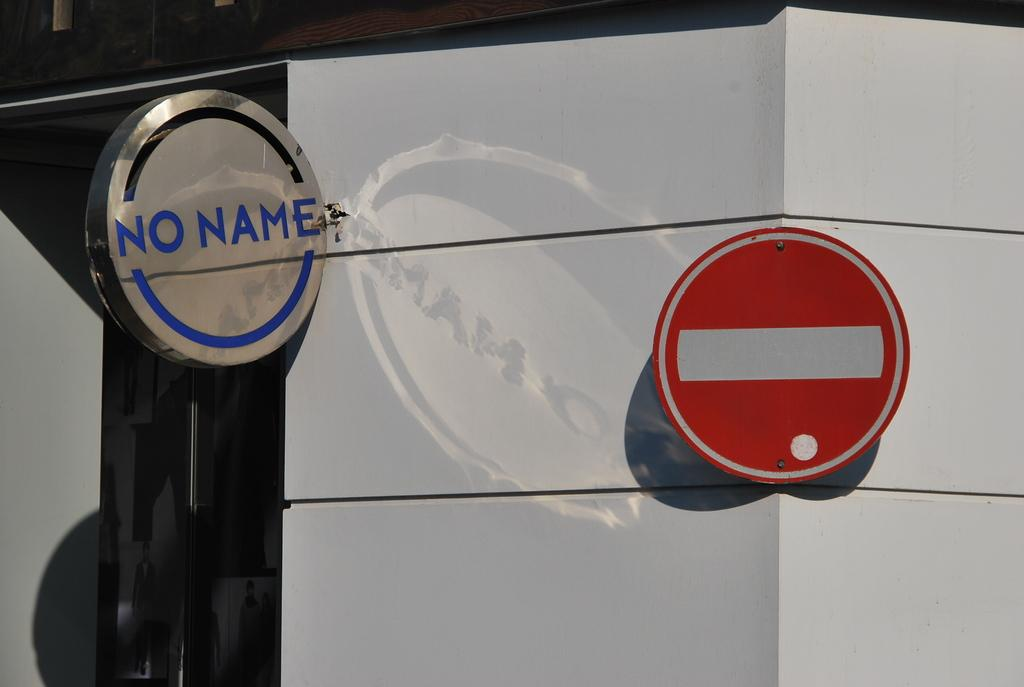What can be seen on the wall in the image? There are sign boards on the wall in the image. What type of lipstick is the daughter using in the image? There is no daughter or lipstick present in the image; it only features sign boards on the wall. 